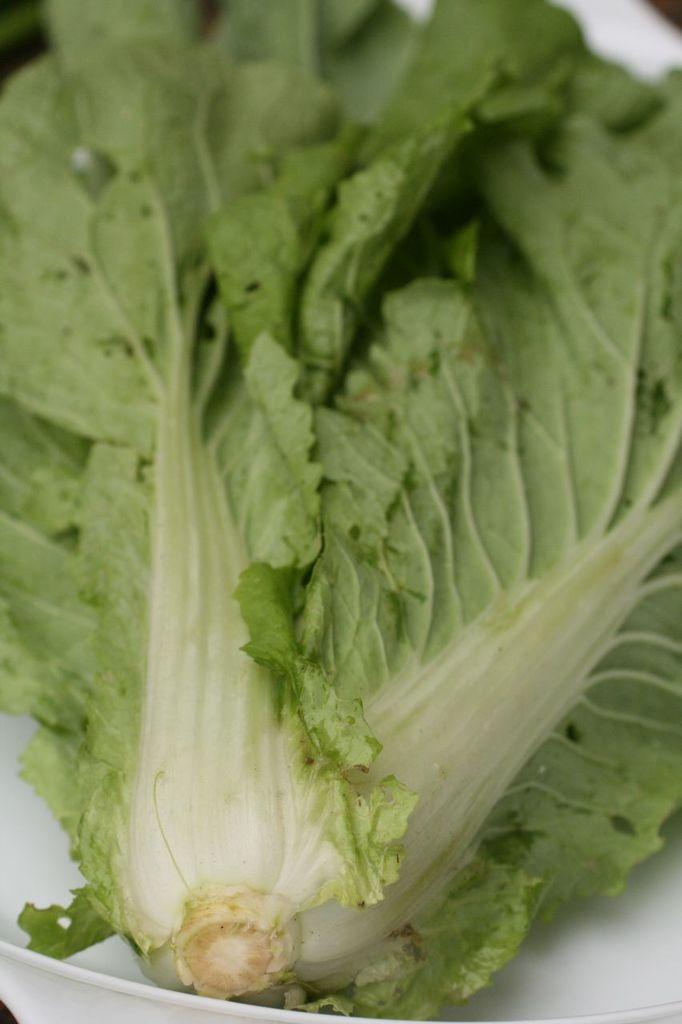What is the main subject of the image? The main subject of the image is a part of a vegetable. How is the vegetable presented in the image? The vegetable is in a plate. What advice do the women in the image give about the yam? There are no women or yams present in the image; it only features a part of a vegetable in a plate. 